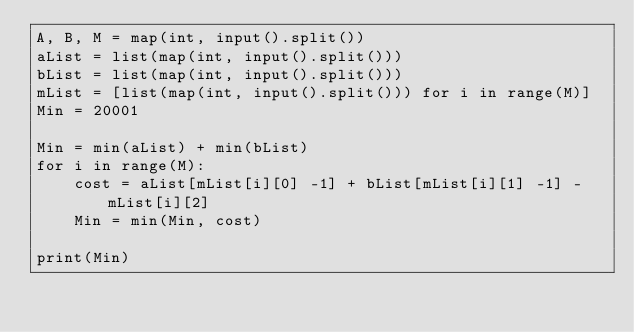<code> <loc_0><loc_0><loc_500><loc_500><_Python_>A, B, M = map(int, input().split())
aList = list(map(int, input().split()))
bList = list(map(int, input().split()))
mList = [list(map(int, input().split())) for i in range(M)]
Min = 20001

Min = min(aList) + min(bList)
for i in range(M):
    cost = aList[mList[i][0] -1] + bList[mList[i][1] -1] - mList[i][2]
    Min = min(Min, cost)

print(Min)</code> 